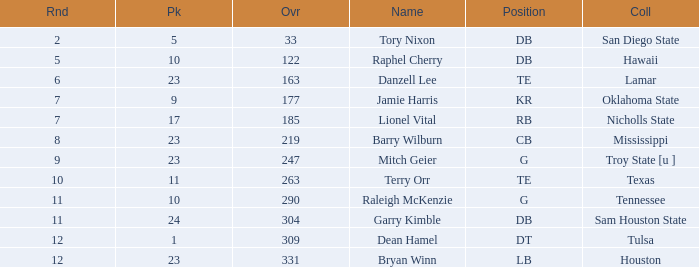In which round does the topmost one have a pick less than 10 and a name as tory nixon? 2.0. 